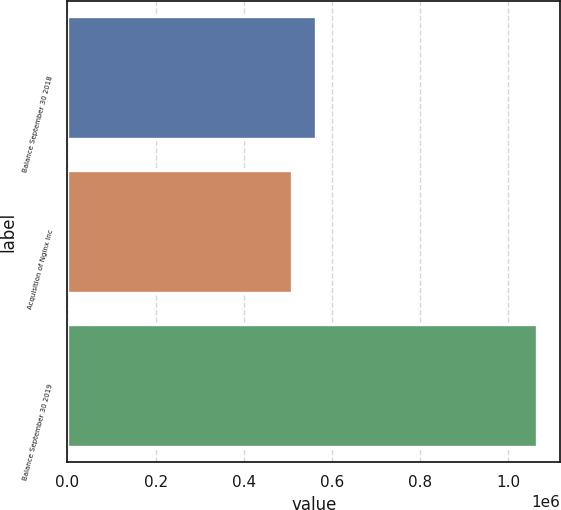Convert chart. <chart><loc_0><loc_0><loc_500><loc_500><bar_chart><fcel>Balance September 30 2018<fcel>Acquisition of Nginx Inc<fcel>Balance September 30 2019<nl><fcel>565010<fcel>509414<fcel>1.06538e+06<nl></chart> 